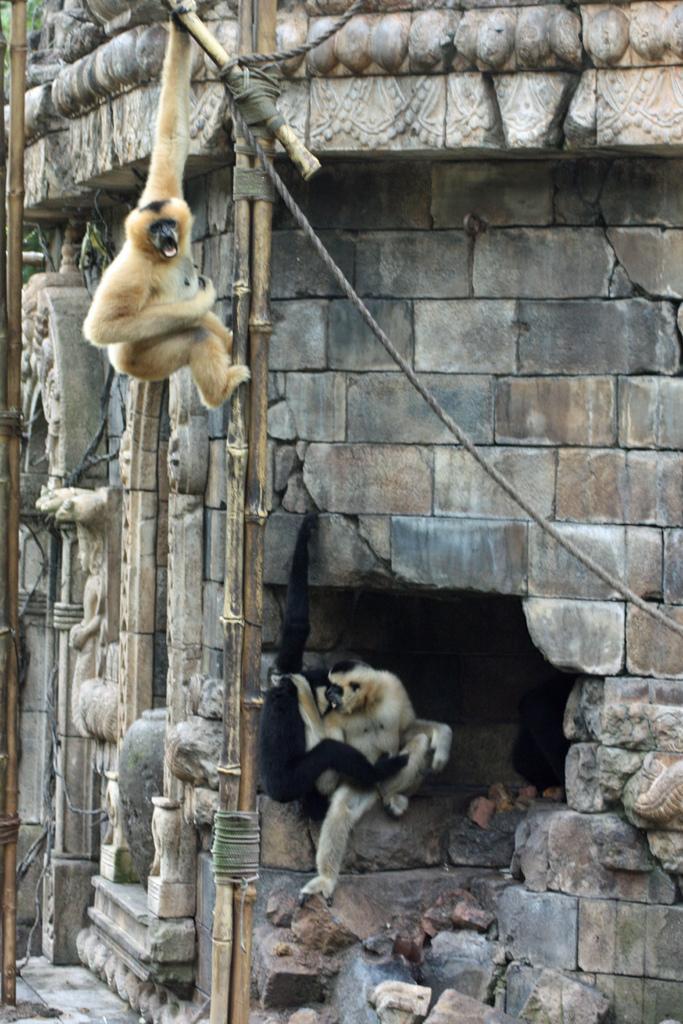Describe this image in one or two sentences. In this image we can see there is a monkey climbing on the wooden stick, and few monkeys are sitting in the rocks of a building. 